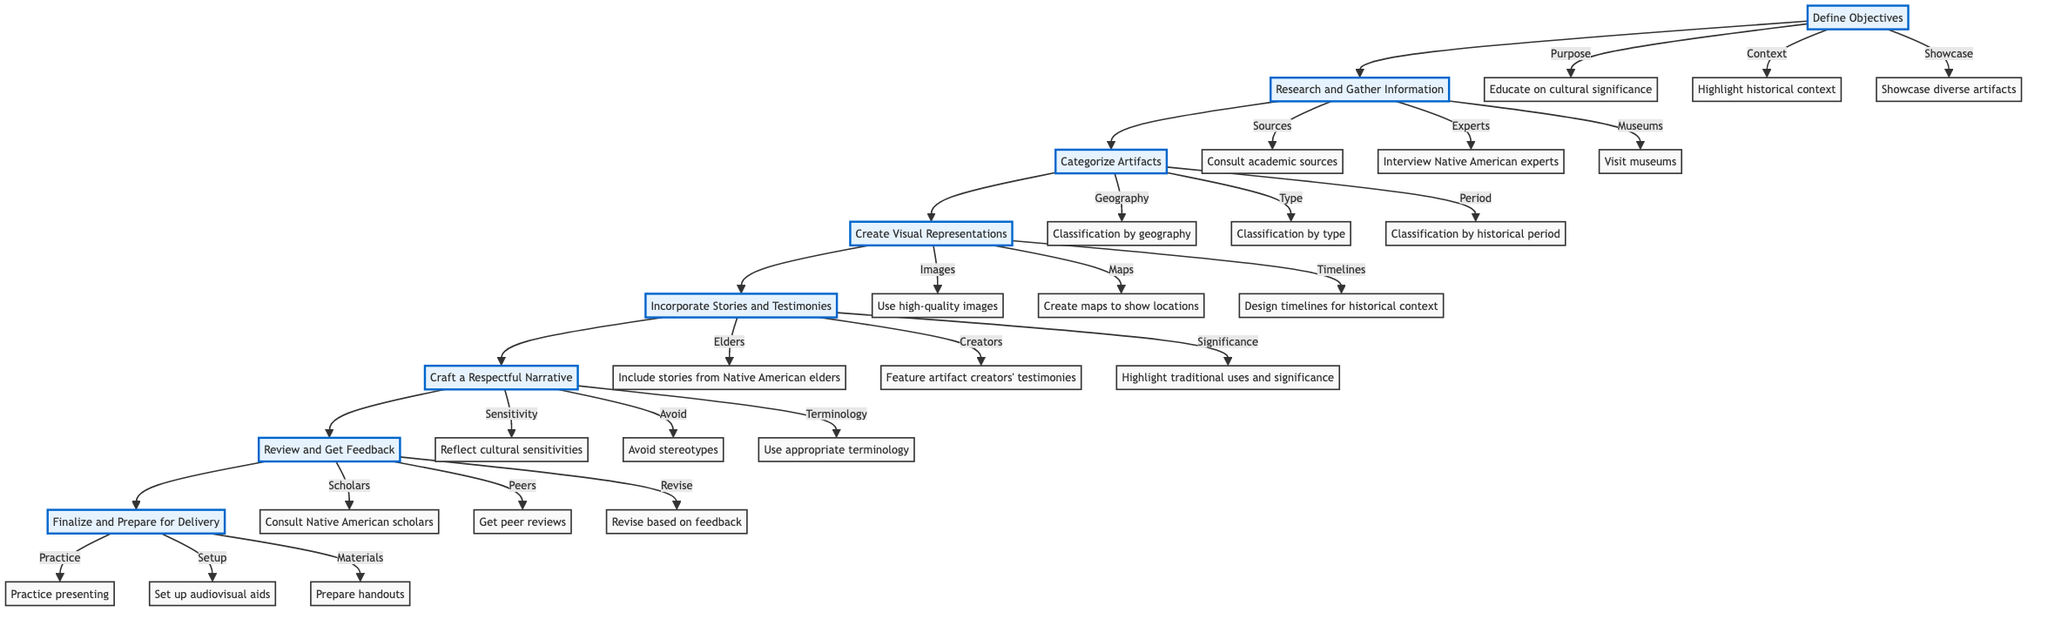What is the first step in the diagram? The flowchart indicates that the first step in the instruction is to "Define Objectives." This is directly linked as the first node in the sequence of steps.
Answer: Define Objectives How many main steps are there in the process? By counting the main nodes in the flowchart, there are a total of eight primary steps leading from defining objectives to final preparations.
Answer: Eight Which component focuses on visual aids? The "Create Visual Representations" component is specifically aimed at design elements necessary for the presentation, such as images and maps.
Answer: Create Visual Representations What should be included when incorporating narratives? The flowchart suggests including stories from Native American elders, among other components, to add depth to the presentation.
Answer: Include stories from Native American elders What is the relationship between "Review and Get Feedback" and "Finalize and Prepare for Delivery"? "Review and Get Feedback" must come before "Finalize and Prepare for Delivery," as feedback helps refine the presentation before final preparations can be made.
Answer: Sequential relationship What type of classification is suggested for artifacts based on location? The flowchart indicates that artifacts should be classified by geography, such as regions like the Great Plains or Southwest.
Answer: Classification by geography Which step involves consulting scholars? The step "Review and Get Feedback" includes the action of consulting Native American scholars to evaluate the presentation draft effectively.
Answer: Review and Get Feedback What does the "Craft a Respectful Narrative" component emphasize? This step emphasizes reflecting cultural sensitivities and avoiding stereotypes to maintain respect in the presentation.
Answer: Reflect cultural sensitivities How are artifacts categorized? Artifacts are categorized by geography, type, and historical period, providing several ways to organize information.
Answer: Classification by geography, type, historical period 